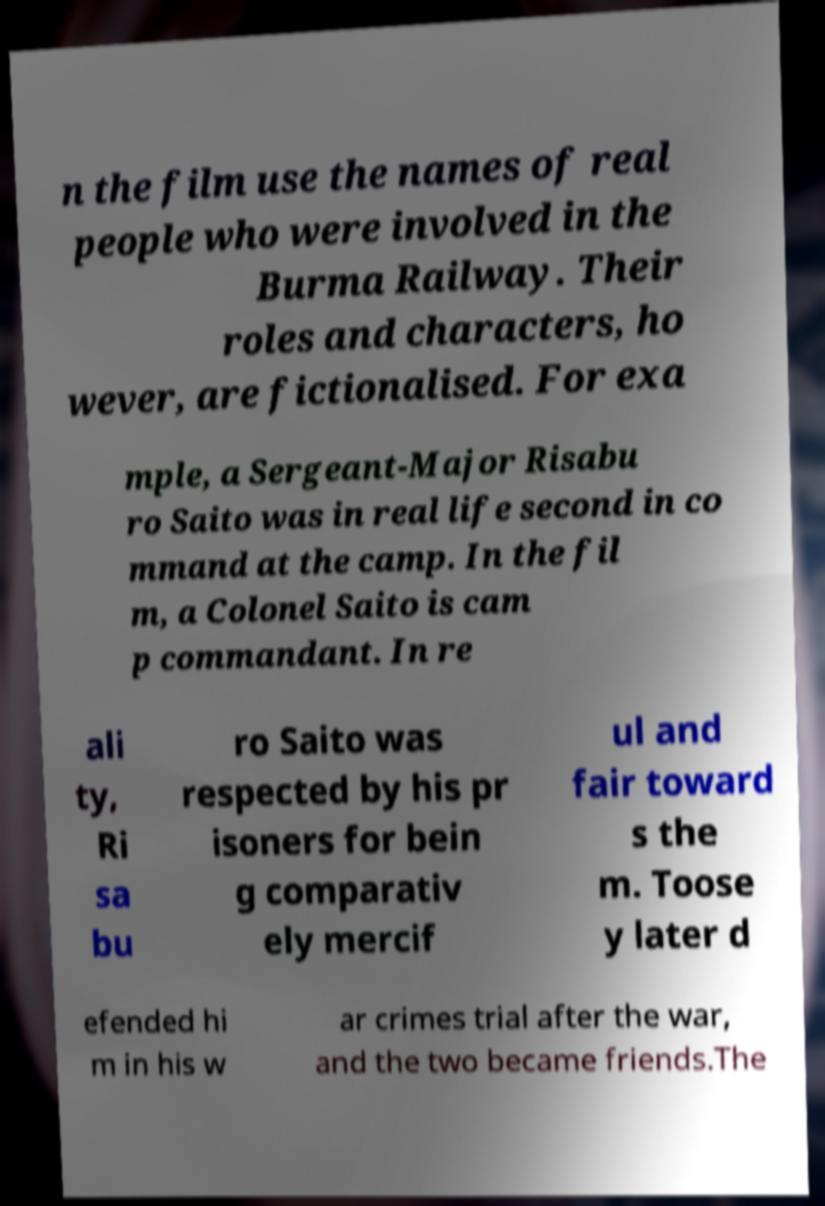I need the written content from this picture converted into text. Can you do that? n the film use the names of real people who were involved in the Burma Railway. Their roles and characters, ho wever, are fictionalised. For exa mple, a Sergeant-Major Risabu ro Saito was in real life second in co mmand at the camp. In the fil m, a Colonel Saito is cam p commandant. In re ali ty, Ri sa bu ro Saito was respected by his pr isoners for bein g comparativ ely mercif ul and fair toward s the m. Toose y later d efended hi m in his w ar crimes trial after the war, and the two became friends.The 